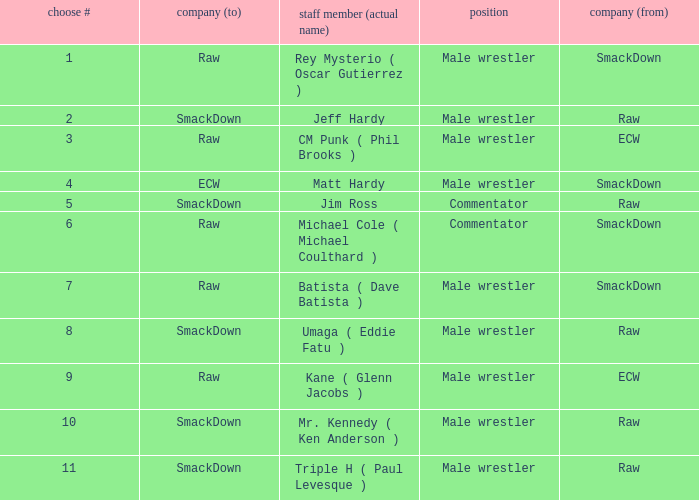Pick # 3 works for which brand? ECW. 